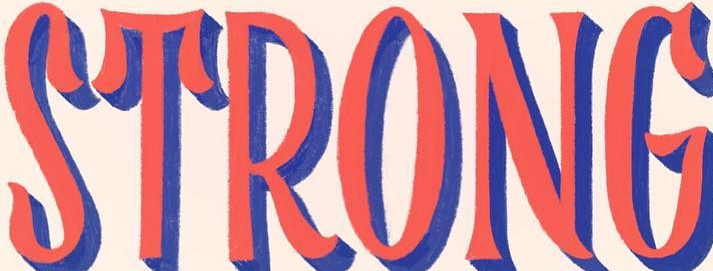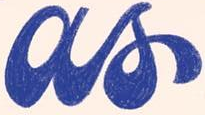Transcribe the words shown in these images in order, separated by a semicolon. STRONG; as 